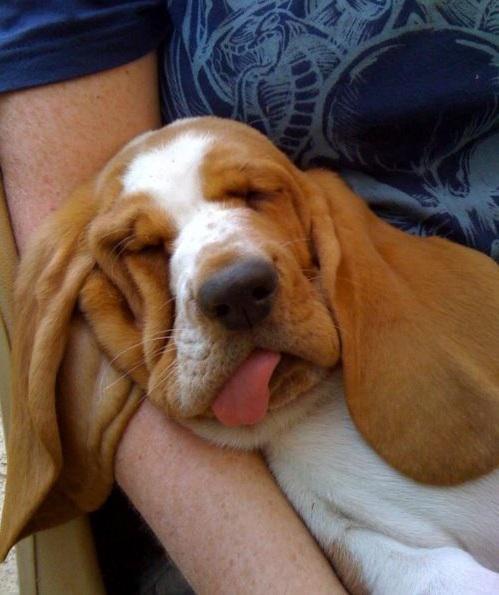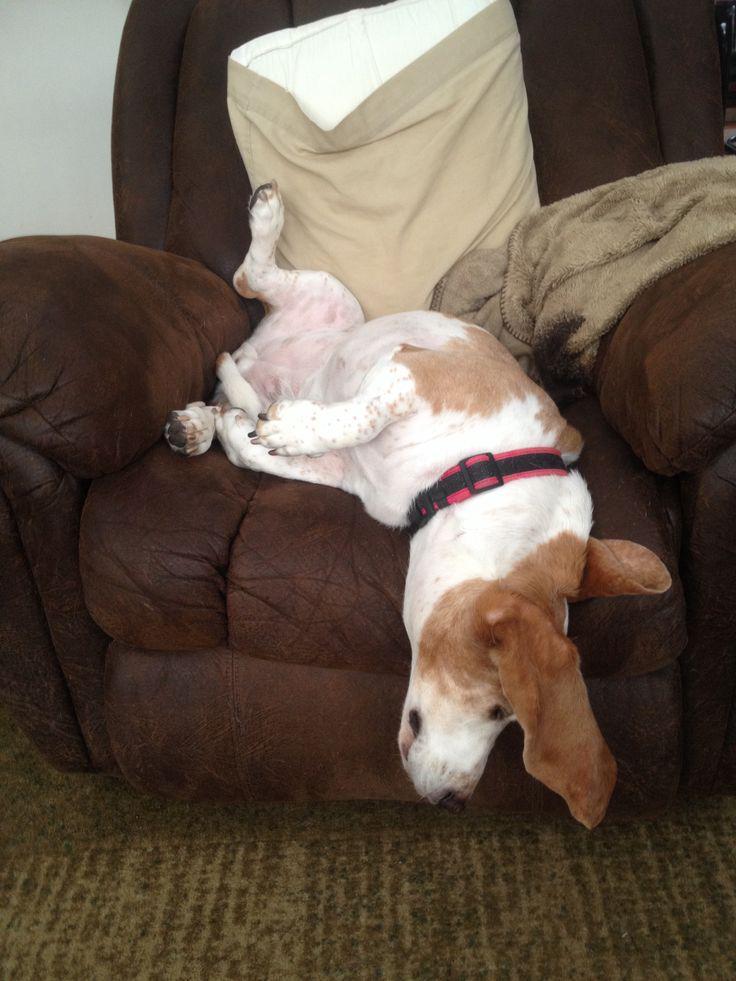The first image is the image on the left, the second image is the image on the right. Examine the images to the left and right. Is the description "One of the images has a dog laying on a log." accurate? Answer yes or no. No. 